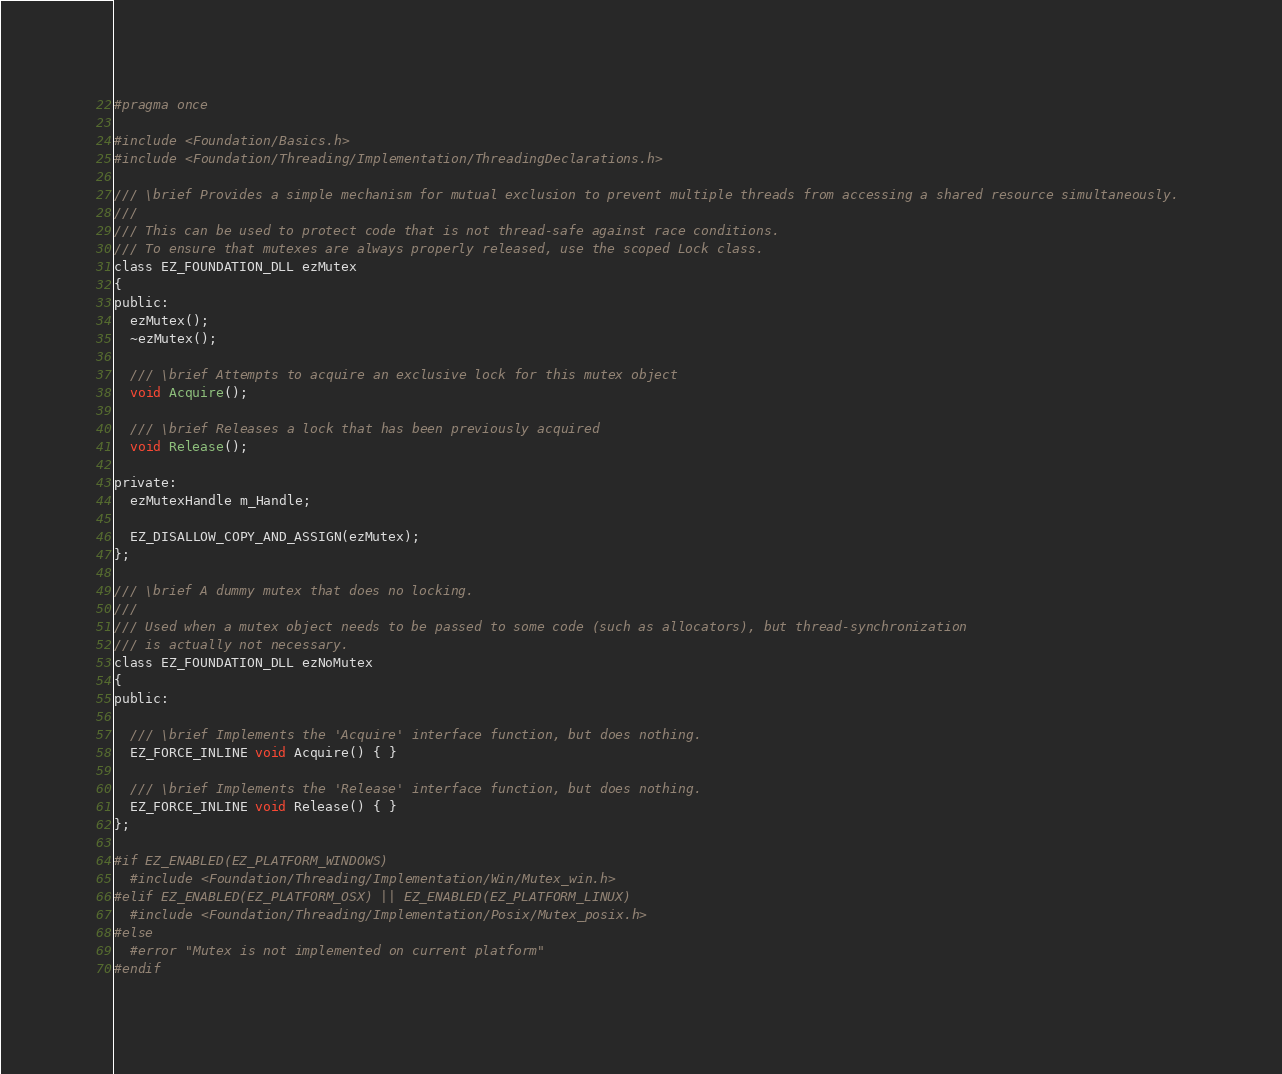<code> <loc_0><loc_0><loc_500><loc_500><_C_>#pragma once

#include <Foundation/Basics.h>
#include <Foundation/Threading/Implementation/ThreadingDeclarations.h>

/// \brief Provides a simple mechanism for mutual exclusion to prevent multiple threads from accessing a shared resource simultaneously. 
///
/// This can be used to protect code that is not thread-safe against race conditions.
/// To ensure that mutexes are always properly released, use the scoped Lock class.
class EZ_FOUNDATION_DLL ezMutex
{
public:
  ezMutex();
  ~ezMutex();
  
  /// \brief Attempts to acquire an exclusive lock for this mutex object
  void Acquire();
  
  /// \brief Releases a lock that has been previously acquired
  void Release();

private:
  ezMutexHandle m_Handle;

  EZ_DISALLOW_COPY_AND_ASSIGN(ezMutex);
};

/// \brief A dummy mutex that does no locking.
///
/// Used when a mutex object needs to be passed to some code (such as allocators), but thread-synchronization
/// is actually not necessary.
class EZ_FOUNDATION_DLL ezNoMutex
{
public:

  /// \brief Implements the 'Acquire' interface function, but does nothing.
  EZ_FORCE_INLINE void Acquire() { }

  /// \brief Implements the 'Release' interface function, but does nothing.
  EZ_FORCE_INLINE void Release() { }
};

#if EZ_ENABLED(EZ_PLATFORM_WINDOWS)
  #include <Foundation/Threading/Implementation/Win/Mutex_win.h>
#elif EZ_ENABLED(EZ_PLATFORM_OSX) || EZ_ENABLED(EZ_PLATFORM_LINUX)
  #include <Foundation/Threading/Implementation/Posix/Mutex_posix.h>
#else
  #error "Mutex is not implemented on current platform"
#endif

</code> 